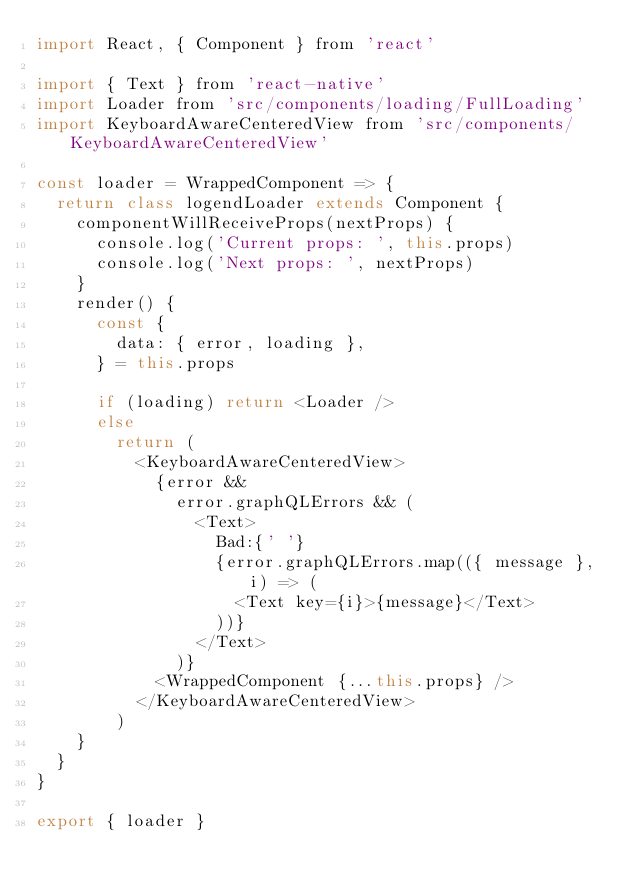<code> <loc_0><loc_0><loc_500><loc_500><_JavaScript_>import React, { Component } from 'react'

import { Text } from 'react-native'
import Loader from 'src/components/loading/FullLoading'
import KeyboardAwareCenteredView from 'src/components/KeyboardAwareCenteredView'

const loader = WrappedComponent => {
  return class logendLoader extends Component {
    componentWillReceiveProps(nextProps) {
      console.log('Current props: ', this.props)
      console.log('Next props: ', nextProps)
    }
    render() {
      const {
        data: { error, loading },
      } = this.props

      if (loading) return <Loader />
      else
        return (
          <KeyboardAwareCenteredView>
            {error &&
              error.graphQLErrors && (
                <Text>
                  Bad:{' '}
                  {error.graphQLErrors.map(({ message }, i) => (
                    <Text key={i}>{message}</Text>
                  ))}
                </Text>
              )}
            <WrappedComponent {...this.props} />
          </KeyboardAwareCenteredView>
        )
    }
  }
}

export { loader }
</code> 